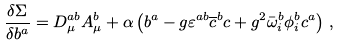<formula> <loc_0><loc_0><loc_500><loc_500>\frac { \delta \Sigma } { \delta b ^ { a } } = D _ { \mu } ^ { a b } A _ { \mu } ^ { b } + \alpha \left ( b ^ { a } - g \varepsilon ^ { a b } \overline { c } ^ { b } c + g ^ { 2 } \bar { \omega } _ { i } ^ { b } \phi _ { i } ^ { b } c ^ { a } \right ) \, ,</formula> 